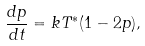<formula> <loc_0><loc_0><loc_500><loc_500>\frac { d p } { d t } = k T ^ { * } ( 1 - 2 p ) ,</formula> 